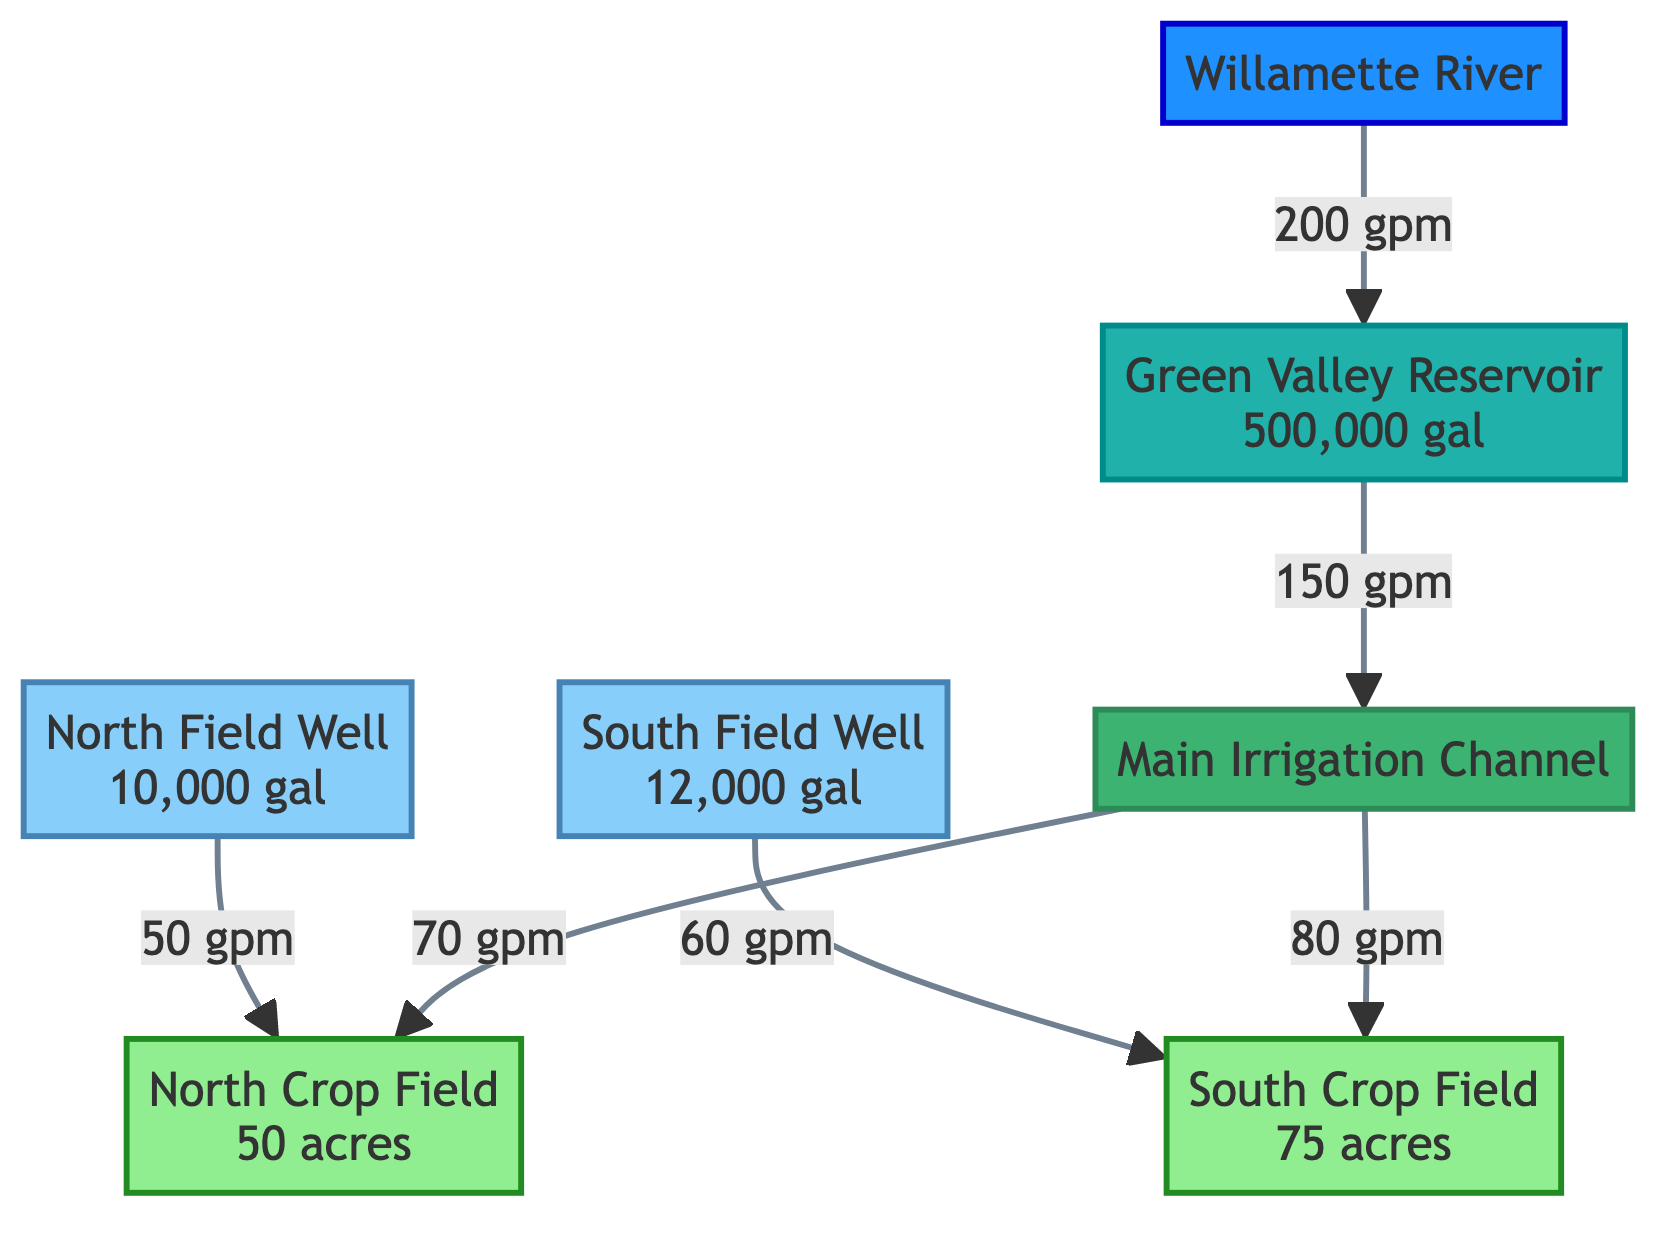What is the capacity of the North Field Well? The North Field Well node displays its capacity as 10,000 gallons, which is directly listed in the node information.
Answer: 10,000 gallons What is the flow rate from the Well_1 to Field_1? The edge from Well_1 to Field_1 indicates a flow rate of 50 gallons per minute, which is noted beside the edge in the diagram.
Answer: 50 gallons per minute How many fields are connected in this diagram? The diagram illustrates two fields: North Crop Field and South Crop Field. Therefore, by counting the field nodes, we find a total of two fields connected in the system.
Answer: 2 What type of water source is represented by the node labeled "Green Valley Reservoir"? The node labeled "Green Valley Reservoir" specifies its type as a reservoir, which is indicated in the node type information shown in the diagram.
Answer: Reservoir Which sources connect to the Main Irrigation Channel? The sources that connect to the Main Irrigation Channel are the Green Valley Reservoir and the two fields (North Crop Field and South Crop Field) that receive water from it. This can be confirmed by looking at the incoming edges from the reservoir and outgoing edges to the fields.
Answer: Green Valley Reservoir What is the total flow capacity of both wells combined? Adding the capacities of both wells gives a combined total: 10,000 gallons from North Field Well and 12,000 gallons from South Field Well, resulting in a total of 22,000 gallons. This calculation is derived from the capacities listed in the diagram.
Answer: 22,000 gallons How much water is flowing into the South Crop Field through its connected sources? There are two sources supplying water to the South Crop Field: the South Field Well with a flow of 60 gallons per minute and the Main Irrigation Channel with a flow of 80 gallons per minute. Adding these two flows gives a total inflow of 140 gallons per minute to the field. This sum can be calculated by examining the edge directions and flow rates in the diagram.
Answer: 140 gallons per minute What is the maximum capacity of the Green Valley Reservoir? The Green Valley Reservoir has a maximum capacity of 500,000 gallons, as indicated in the node labeled "Green Valley Reservoir."
Answer: 500,000 gallons What type is the Willamette River? The Willamette River node clearly identifies its type as a river, which is a specific label attached to that node in the diagram.
Answer: River 